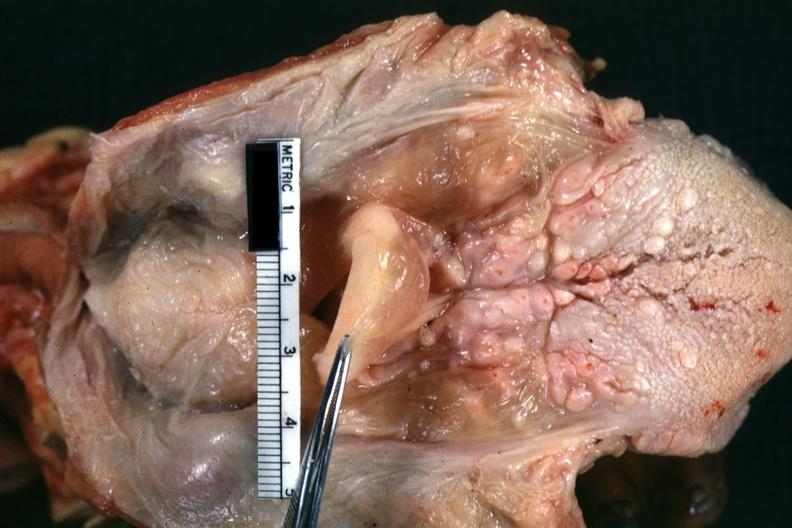s larynx present?
Answer the question using a single word or phrase. Yes 